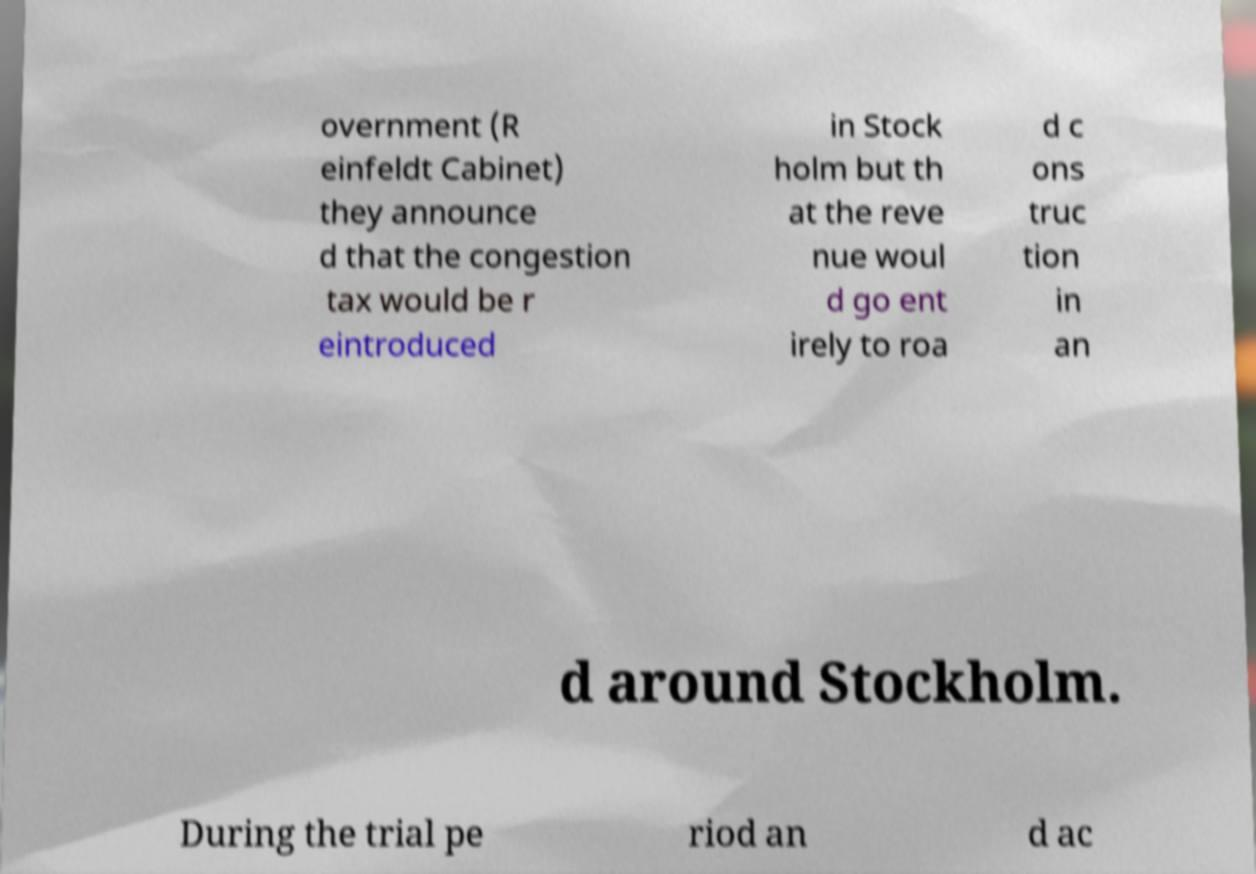Could you assist in decoding the text presented in this image and type it out clearly? overnment (R einfeldt Cabinet) they announce d that the congestion tax would be r eintroduced in Stock holm but th at the reve nue woul d go ent irely to roa d c ons truc tion in an d around Stockholm. During the trial pe riod an d ac 